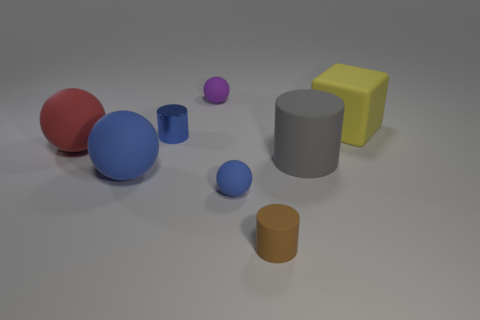Subtract 1 spheres. How many spheres are left? 3 Add 2 small brown cylinders. How many objects exist? 10 Subtract all cylinders. How many objects are left? 5 Subtract 1 yellow cubes. How many objects are left? 7 Subtract all shiny cubes. Subtract all large red spheres. How many objects are left? 7 Add 5 big blue balls. How many big blue balls are left? 6 Add 3 yellow rubber balls. How many yellow rubber balls exist? 3 